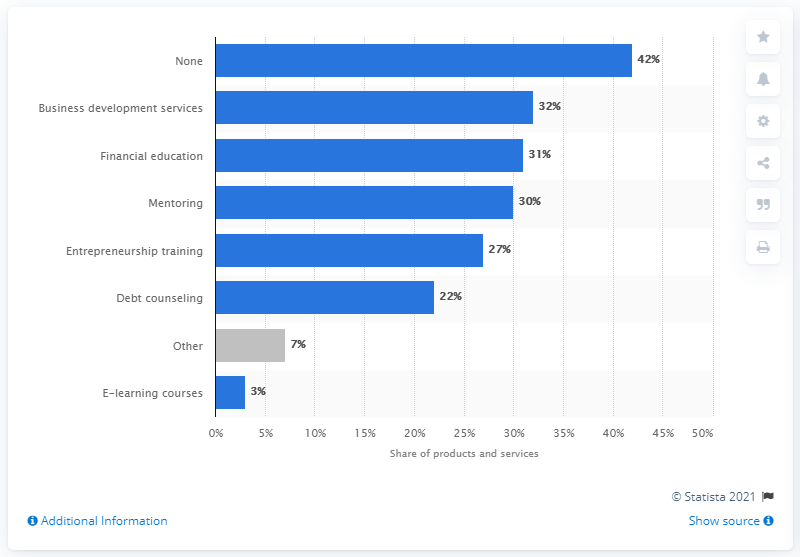Identify some key points in this picture. Nearly 32% of European microcredit institutions offer business development services. In 2015, the most popular non-financial product on the market was business development services. 